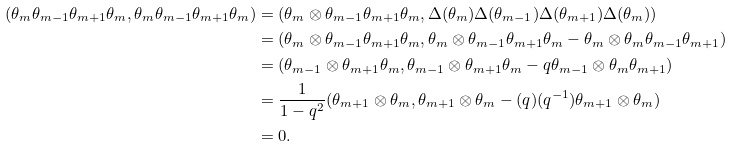<formula> <loc_0><loc_0><loc_500><loc_500>( \theta _ { m } \theta _ { m - 1 } \theta _ { m + 1 } \theta _ { m } , \theta _ { m } \theta _ { m - 1 } \theta _ { m + 1 } \theta _ { m } ) & = ( \theta _ { m } \otimes \theta _ { m - 1 } \theta _ { m + 1 } \theta _ { m } , \Delta ( \theta _ { m } ) \Delta ( \theta _ { m - 1 } ) \Delta ( \theta _ { m + 1 } ) \Delta ( \theta _ { m } ) ) \\ & = ( \theta _ { m } \otimes \theta _ { m - 1 } \theta _ { m + 1 } \theta _ { m } , \theta _ { m } \otimes \theta _ { m - 1 } \theta _ { m + 1 } \theta _ { m } - \theta _ { m } \otimes \theta _ { m } \theta _ { m - 1 } \theta _ { m + 1 } ) \\ & = ( \theta _ { m - 1 } \otimes \theta _ { m + 1 } \theta _ { m } , \theta _ { m - 1 } \otimes \theta _ { m + 1 } \theta _ { m } - q \theta _ { m - 1 } \otimes \theta _ { m } \theta _ { m + 1 } ) \\ & = \frac { 1 } { 1 - q ^ { 2 } } ( \theta _ { m + 1 } \otimes \theta _ { m } , \theta _ { m + 1 } \otimes \theta _ { m } - ( q ) ( q ^ { - 1 } ) \theta _ { m + 1 } \otimes \theta _ { m } ) \\ & = 0 .</formula> 